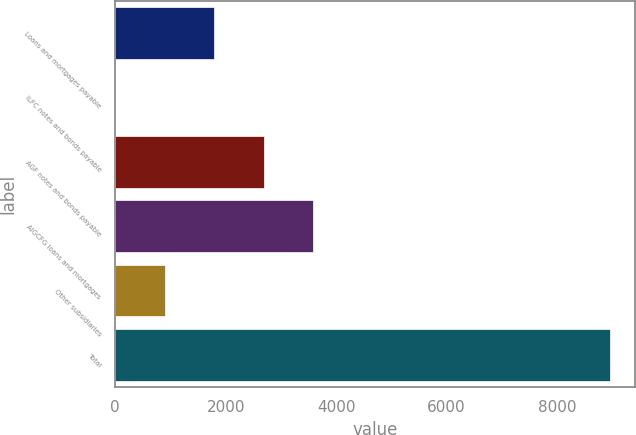Convert chart to OTSL. <chart><loc_0><loc_0><loc_500><loc_500><bar_chart><fcel>Loans and mortgages payable<fcel>ILFC notes and bonds payable<fcel>AGF notes and bonds payable<fcel>AIGCFG loans and mortgages<fcel>Other subsidiaries<fcel>Total<nl><fcel>1794.2<fcel>3<fcel>2689.8<fcel>3585.4<fcel>898.6<fcel>8959<nl></chart> 